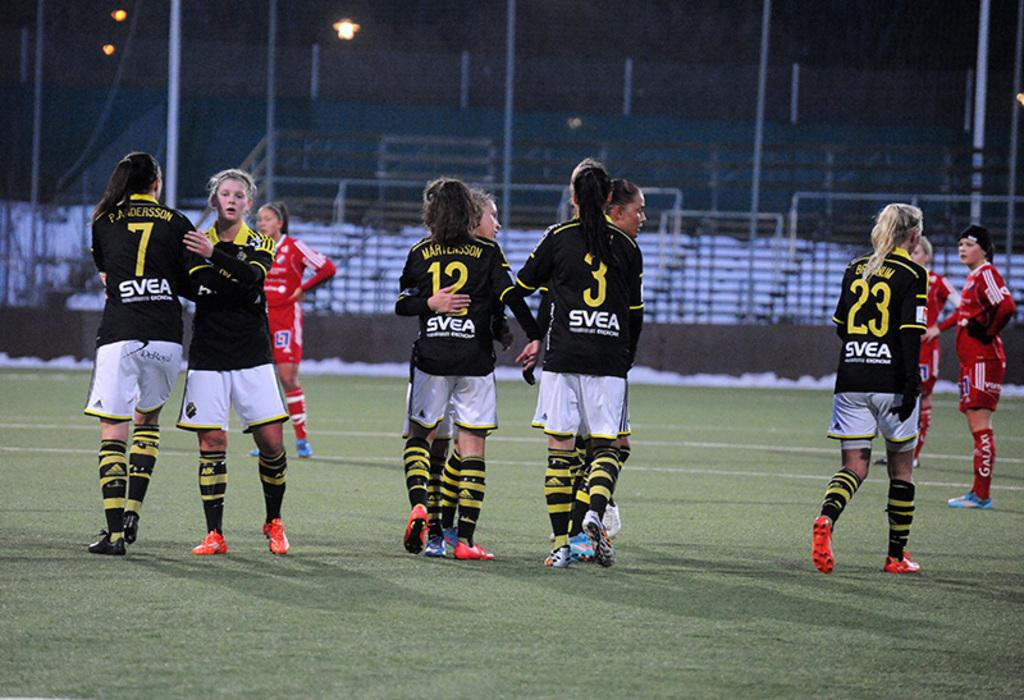<image>
Write a terse but informative summary of the picture. Several female soccer players with the name SVEA on the back of their jersey's are hugging and giving one another pats on the back on a soccer field. 